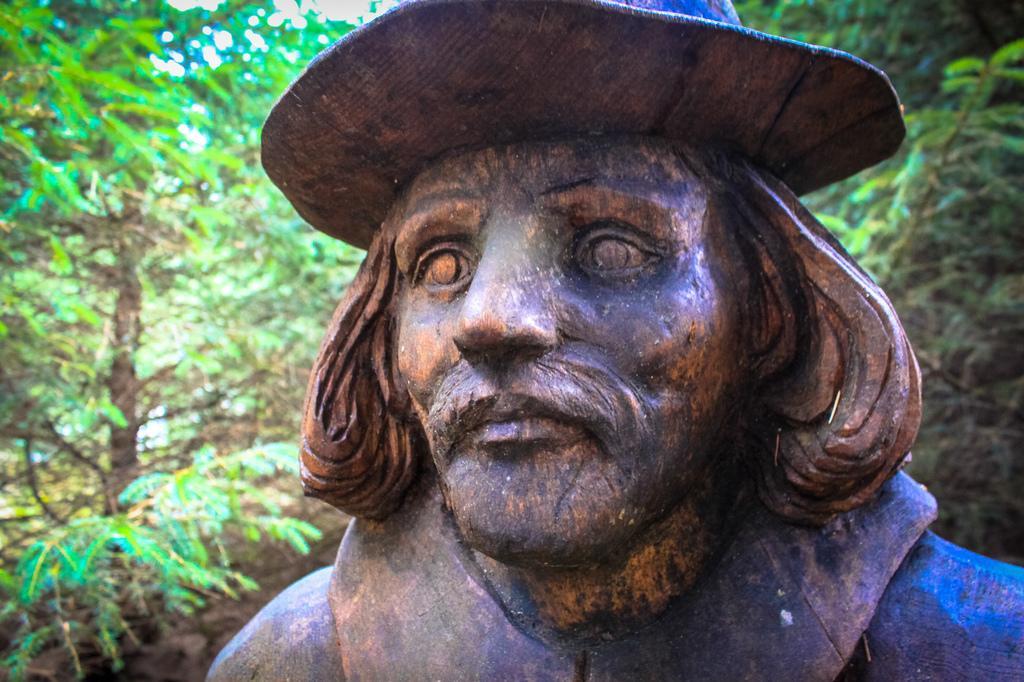How would you summarize this image in a sentence or two? In this image I can see the person statue. In the background I can see few trees in green color. 